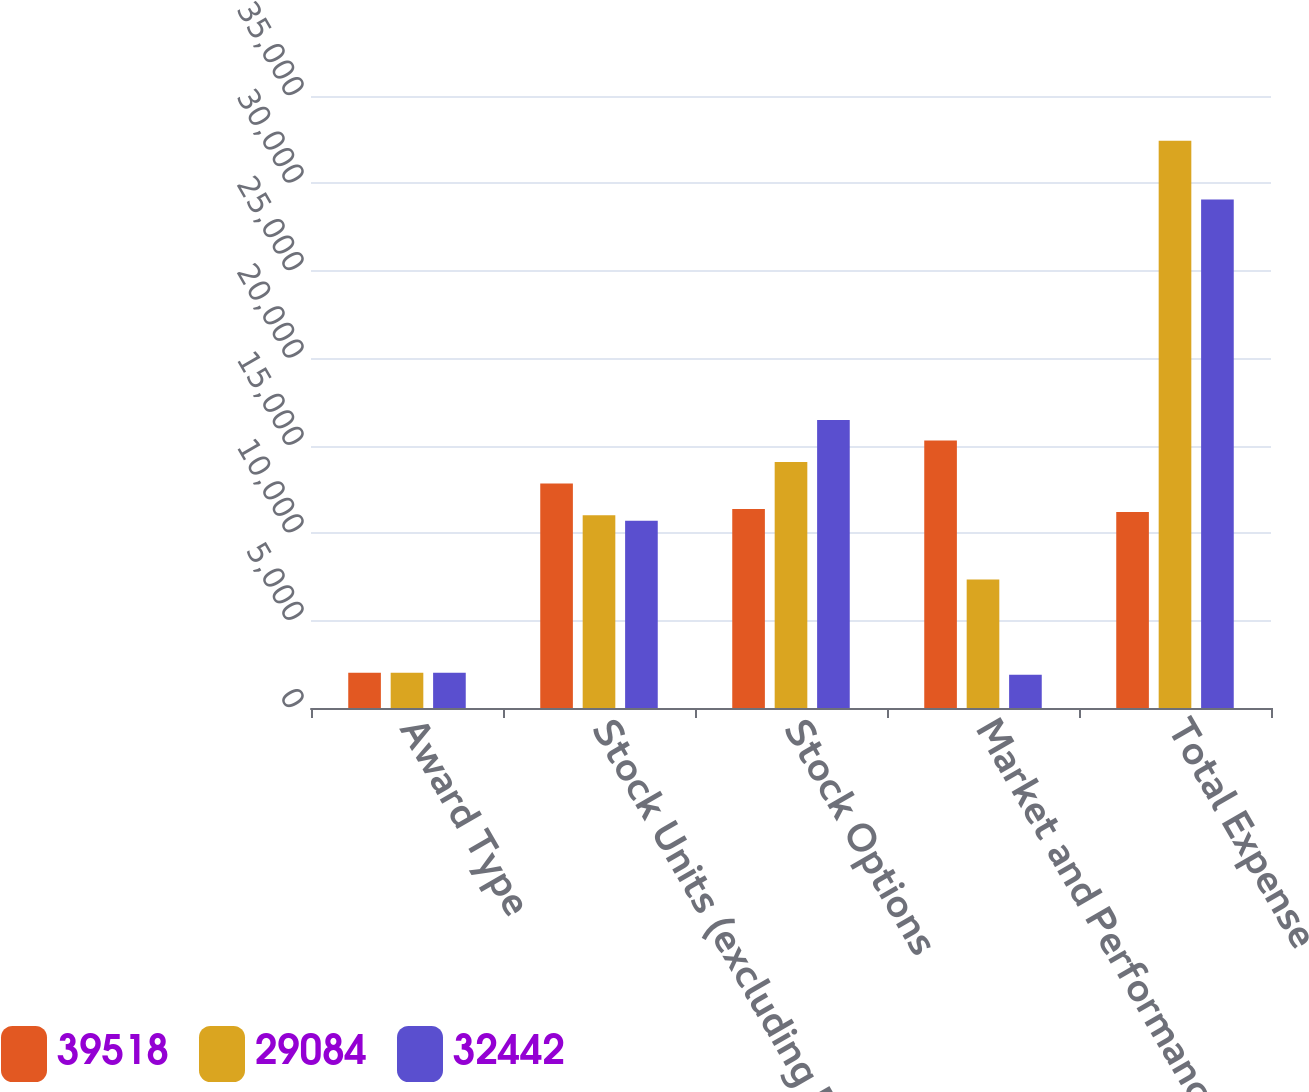<chart> <loc_0><loc_0><loc_500><loc_500><stacked_bar_chart><ecel><fcel>Award Type<fcel>Stock Units (excluding Market<fcel>Stock Options<fcel>Market and Performance Awards<fcel>Total Expense<nl><fcel>39518<fcel>2013<fcel>12836<fcel>11385<fcel>15297<fcel>11203<nl><fcel>29084<fcel>2012<fcel>11021<fcel>14067<fcel>7354<fcel>32442<nl><fcel>32442<fcel>2011<fcel>10710<fcel>16468<fcel>1906<fcel>29084<nl></chart> 